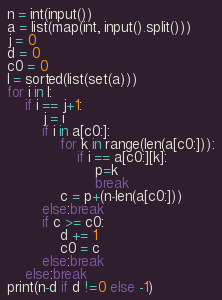<code> <loc_0><loc_0><loc_500><loc_500><_Python_>n = int(input())
a = list(map(int, input().split()))
j = 0
d = 0
c0 = 0
l = sorted(list(set(a)))
for i in l:
    if i == j+1:
        j = i
        if i in a[c0:]:
            for k in range(len(a[c0:])):
                if i == a[c0:][k]:
                    p=k
                    break
            c = p+(n-len(a[c0:]))
        else:break
        if c >= c0:
            d += 1
            c0 = c
        else:break
    else:break
print(n-d if d !=0 else -1)</code> 